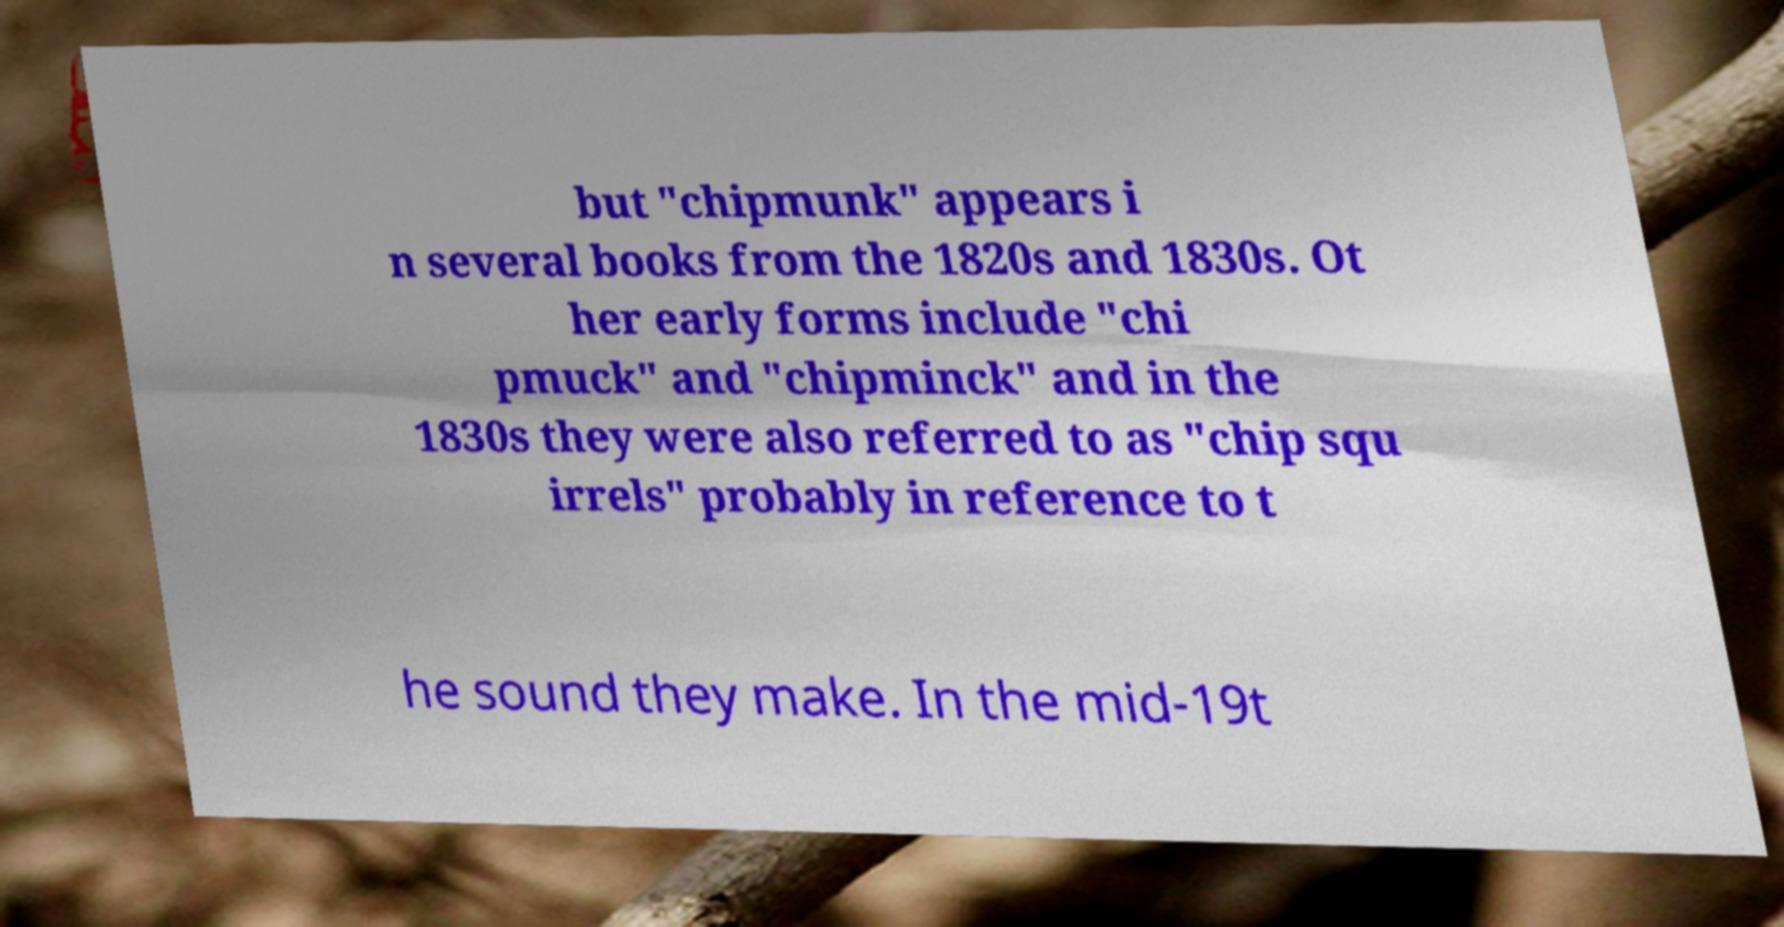Please identify and transcribe the text found in this image. but "chipmunk" appears i n several books from the 1820s and 1830s. Ot her early forms include "chi pmuck" and "chipminck" and in the 1830s they were also referred to as "chip squ irrels" probably in reference to t he sound they make. In the mid-19t 